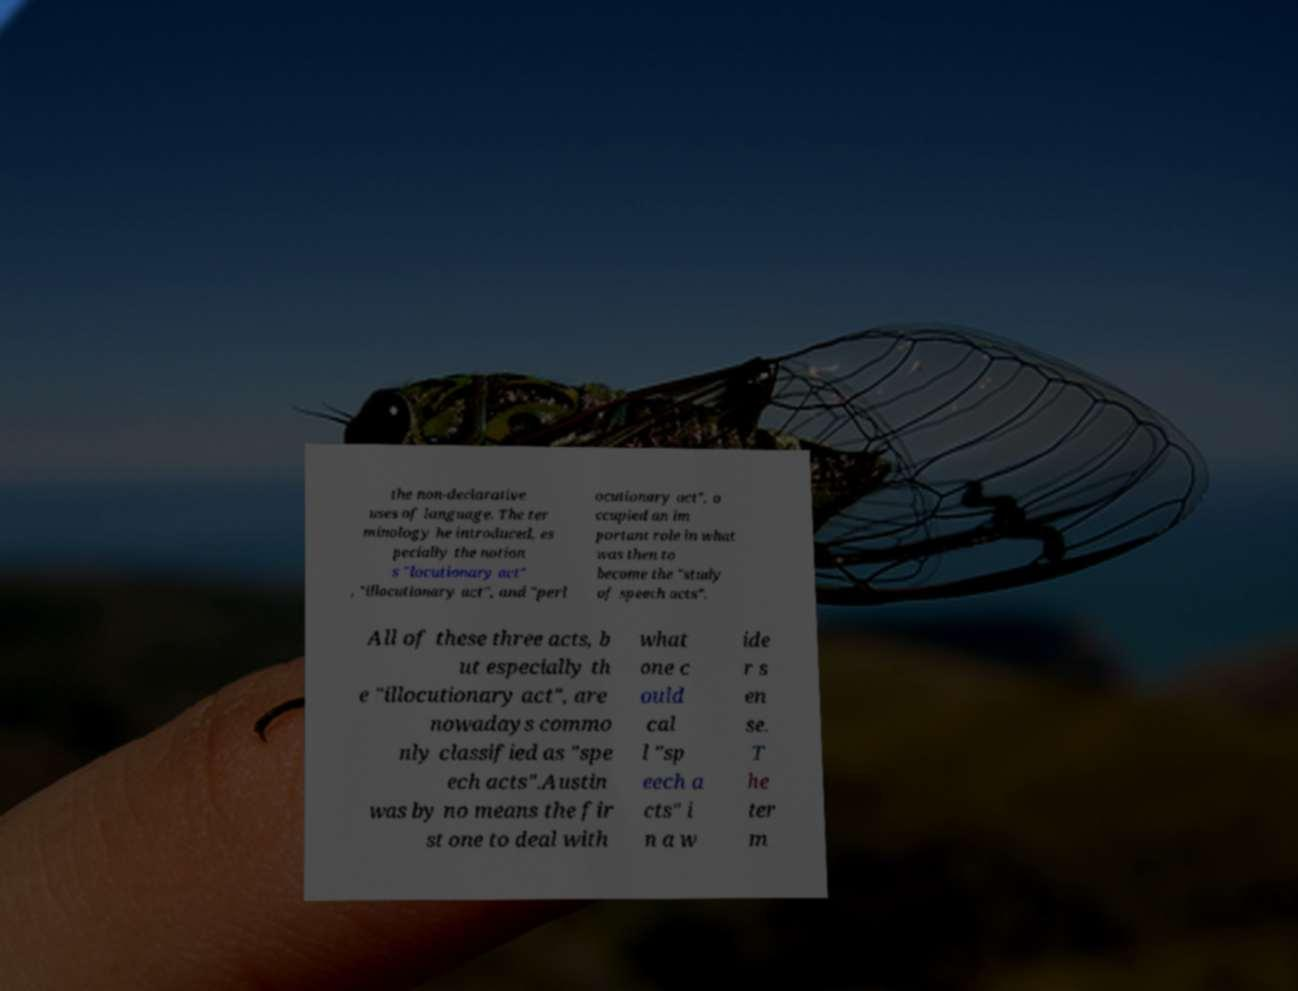Could you extract and type out the text from this image? the non-declarative uses of language. The ter minology he introduced, es pecially the notion s "locutionary act" , "illocutionary act", and "perl ocutionary act", o ccupied an im portant role in what was then to become the "study of speech acts". All of these three acts, b ut especially th e "illocutionary act", are nowadays commo nly classified as "spe ech acts".Austin was by no means the fir st one to deal with what one c ould cal l "sp eech a cts" i n a w ide r s en se. T he ter m 